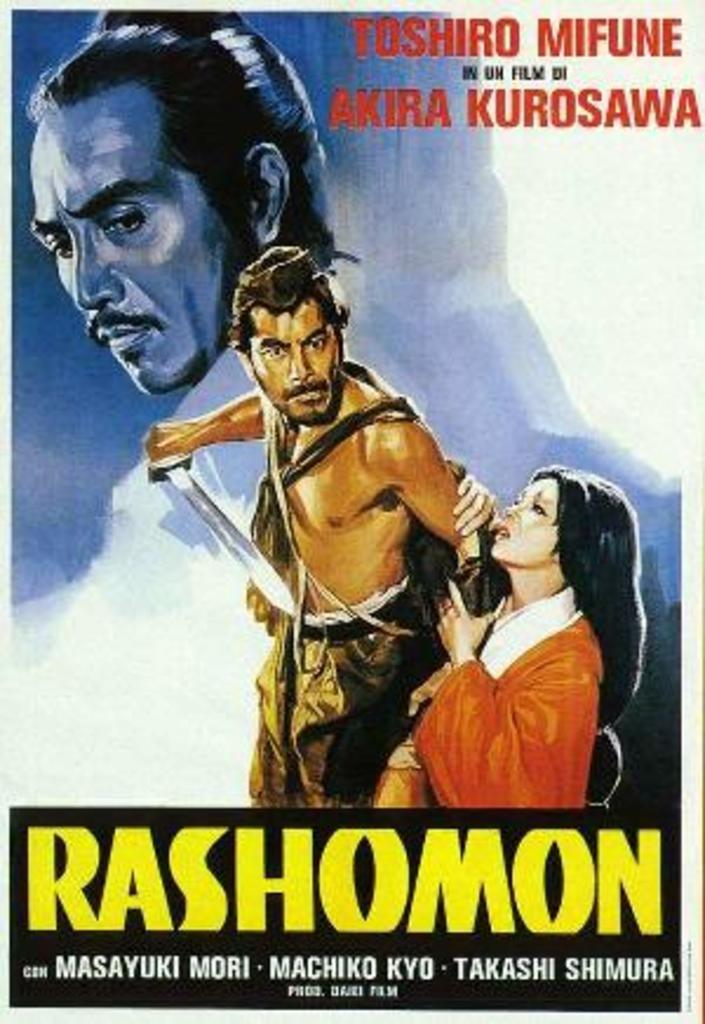<image>
Give a short and clear explanation of the subsequent image. A poster for a movie called Rashomon with a man with a sword on it. 